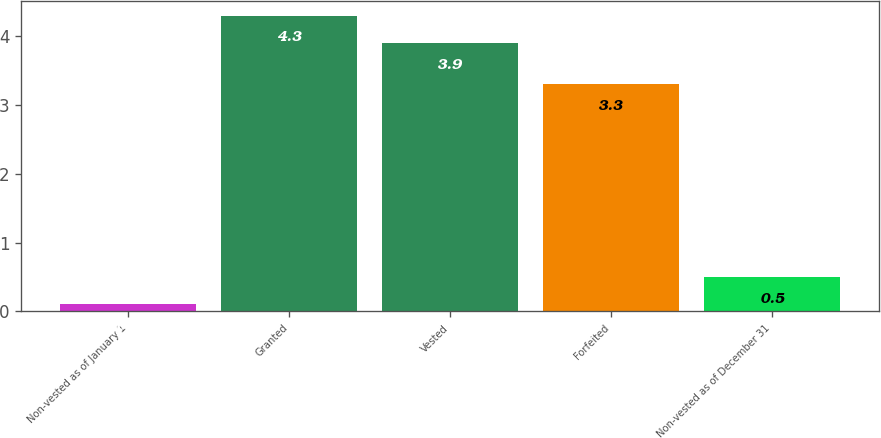Convert chart. <chart><loc_0><loc_0><loc_500><loc_500><bar_chart><fcel>Non-vested as of January 1<fcel>Granted<fcel>Vested<fcel>Forfeited<fcel>Non-vested as of December 31<nl><fcel>0.1<fcel>4.3<fcel>3.9<fcel>3.3<fcel>0.5<nl></chart> 